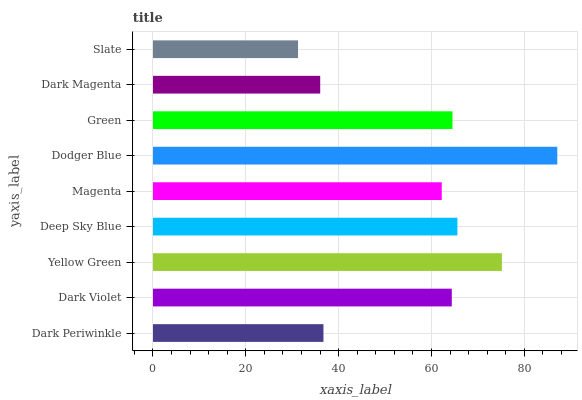Is Slate the minimum?
Answer yes or no. Yes. Is Dodger Blue the maximum?
Answer yes or no. Yes. Is Dark Violet the minimum?
Answer yes or no. No. Is Dark Violet the maximum?
Answer yes or no. No. Is Dark Violet greater than Dark Periwinkle?
Answer yes or no. Yes. Is Dark Periwinkle less than Dark Violet?
Answer yes or no. Yes. Is Dark Periwinkle greater than Dark Violet?
Answer yes or no. No. Is Dark Violet less than Dark Periwinkle?
Answer yes or no. No. Is Dark Violet the high median?
Answer yes or no. Yes. Is Dark Violet the low median?
Answer yes or no. Yes. Is Magenta the high median?
Answer yes or no. No. Is Dark Periwinkle the low median?
Answer yes or no. No. 